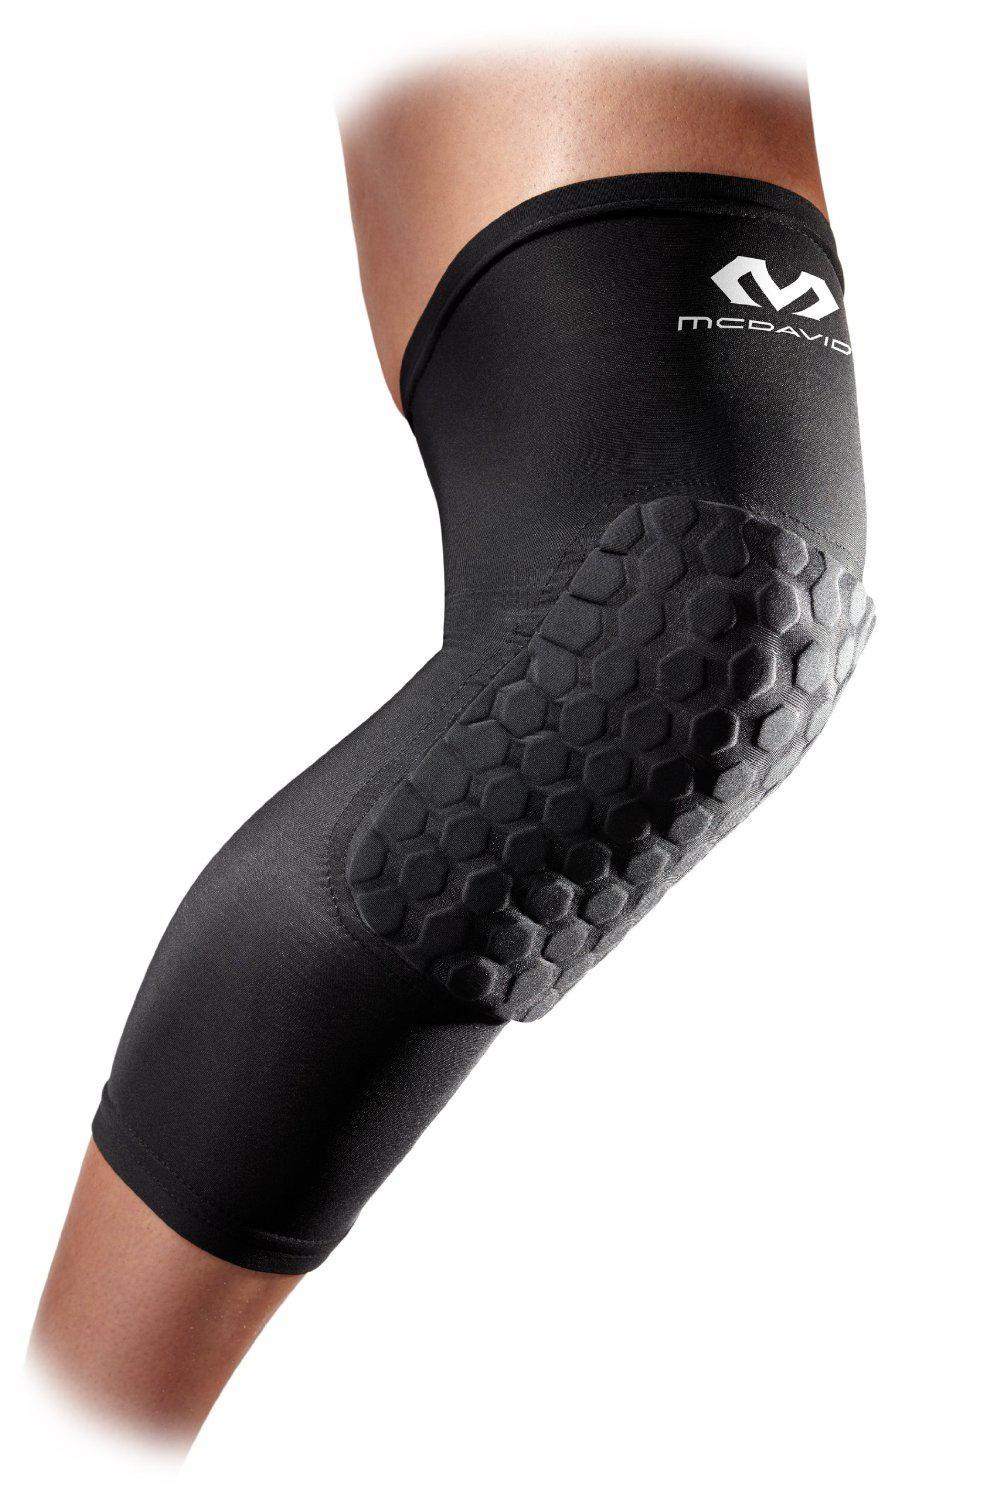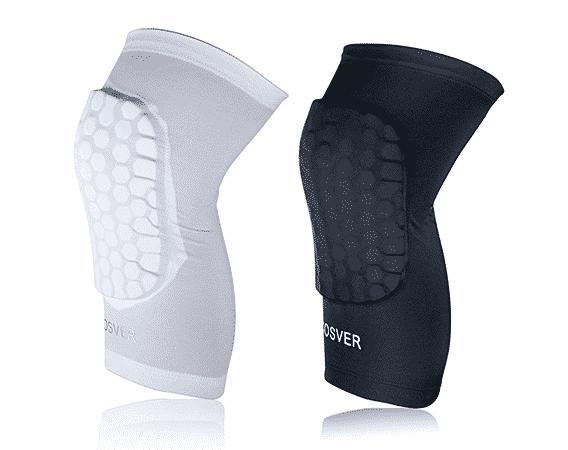The first image is the image on the left, the second image is the image on the right. Evaluate the accuracy of this statement regarding the images: "There are three knee braces in total.". Is it true? Answer yes or no. Yes. The first image is the image on the left, the second image is the image on the right. For the images shown, is this caption "The left and right image contains a total of three knee pads." true? Answer yes or no. Yes. 